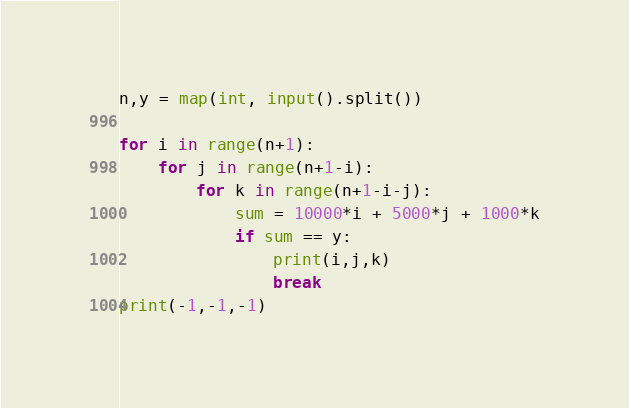<code> <loc_0><loc_0><loc_500><loc_500><_Python_>n,y = map(int, input().split())

for i in range(n+1):
    for j in range(n+1-i):
        for k in range(n+1-i-j):
            sum = 10000*i + 5000*j + 1000*k
            if sum == y:
                print(i,j,k)
                break
print(-1,-1,-1)</code> 